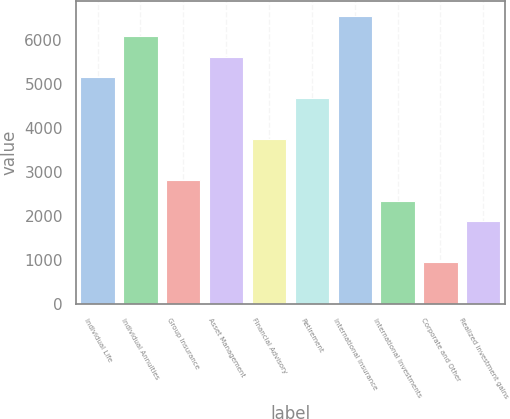Convert chart. <chart><loc_0><loc_0><loc_500><loc_500><bar_chart><fcel>Individual Life<fcel>Individual Annuities<fcel>Group Insurance<fcel>Asset Management<fcel>Financial Advisory<fcel>Retirement<fcel>International Insurance<fcel>International Investments<fcel>Corporate and Other<fcel>Realized investment gains<nl><fcel>5153.3<fcel>6087.9<fcel>2816.8<fcel>5620.6<fcel>3751.4<fcel>4686<fcel>6555.2<fcel>2349.5<fcel>947.6<fcel>1882.2<nl></chart> 